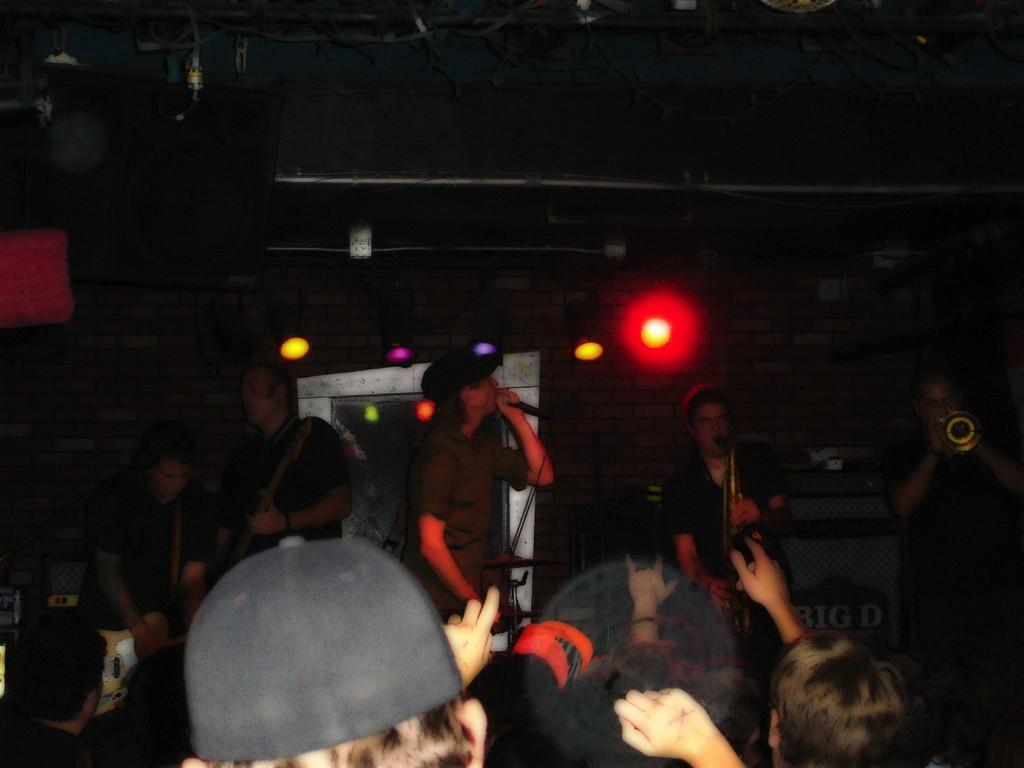How many people are in the image? There are people in the image, but the exact number is not specified. What are some of the people doing in the image? Some people are playing musical instruments, and one person is holding a microphone. What can be seen in the background of the image? There is a wall in the background. What type of lighting is present in the image? There are different lights visible in the image. What type of grass is growing on the dinner table in the image? There is no grass or dinner table present in the image. How do the people in the image react to the unexpected reaction of the audience? There is no mention of an audience or any reactions in the image. 